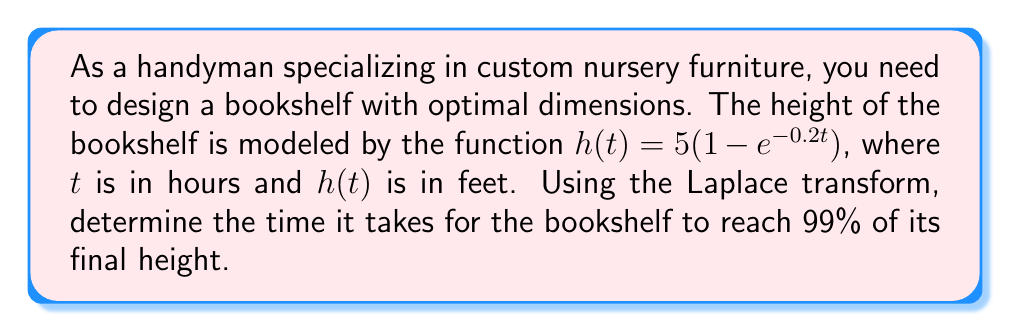Help me with this question. To solve this problem, we'll use the following steps:

1) First, we need to determine the final height of the bookshelf. As $t$ approaches infinity, $e^{-0.2t}$ approaches 0, so:

   $\lim_{t \to \infty} h(t) = 5(1-0) = 5$ feet

2) We want to find when the height reaches 99% of 5 feet, which is 4.95 feet.

3) Set up the equation:
   $5(1-e^{-0.2t}) = 4.95$

4) Solve for $e^{-0.2t}$:
   $1-e^{-0.2t} = 0.99$
   $e^{-0.2t} = 0.01$

5) Take the natural log of both sides:
   $-0.2t = \ln(0.01)$

6) Solve for $t$:
   $t = -\frac{\ln(0.01)}{0.2}$

7) Now, we can use the Laplace transform to verify this result. The Laplace transform of $h(t)$ is:

   $\mathcal{L}\{h(t)\} = H(s) = \frac{5}{s} - \frac{5}{s+0.2}$

8) To find the time domain solution, we need to take the inverse Laplace transform:

   $h(t) = \mathcal{L}^{-1}\{H(s)\} = 5 - 5e^{-0.2t}$

9) This confirms our original function. We can now use the result from step 6 to calculate the time:

   $t = -\frac{\ln(0.01)}{0.2} = 23.03$ hours

Therefore, it takes approximately 23.03 hours for the bookshelf to reach 99% of its final height.
Answer: The time it takes for the bookshelf to reach 99% of its final height is approximately 23.03 hours. 